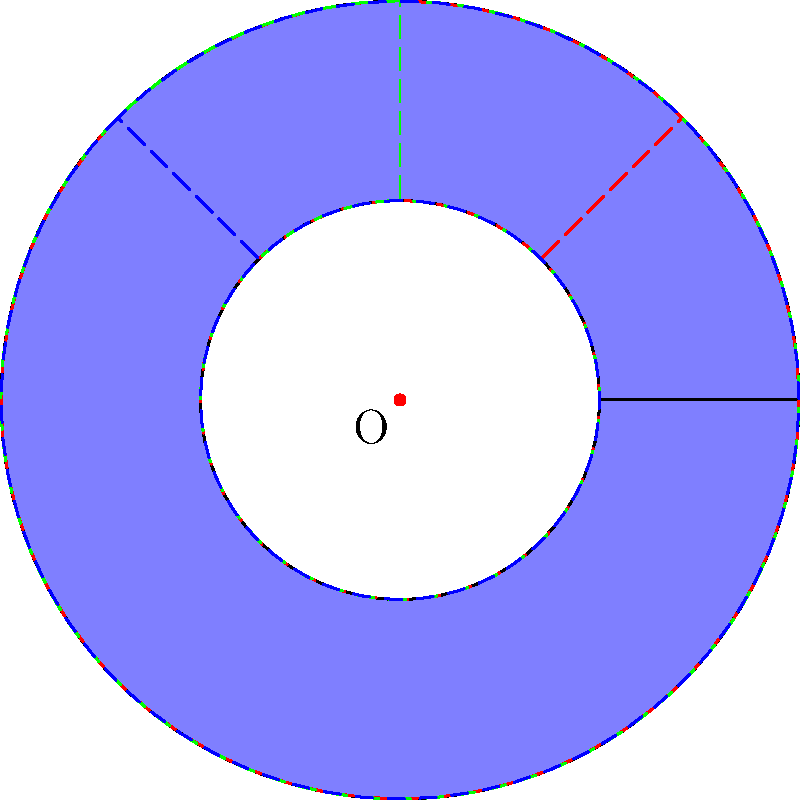As a bakery owner known for unique donut flavors, you're designing a special rotating display for your signature donut. If the donut shape is rotated 45° clockwise around its center point, how many more rotations of 45° each are needed to return the donut to its original position? To solve this problem, let's consider the properties of rotation:

1. A full rotation is 360°.
2. We're rotating in increments of 45°.

To find how many more rotations are needed:

1. Calculate how many 45° rotations make a full 360°:
   $\frac{360°}{45°} = 8$ rotations

2. We've already done one 45° rotation, so we need to subtract 1:
   $8 - 1 = 7$ rotations

Therefore, 7 more rotations of 45° each are needed to return the donut to its original position.

This concept is similar to how you might rotate a display of donuts throughout the day to showcase different flavors, ensuring each one gets equal visibility.
Answer: 7 rotations 